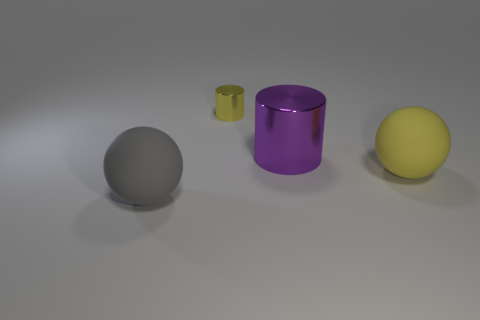Subtract all yellow cylinders. How many cylinders are left? 1 Add 4 big purple metal things. How many objects exist? 8 Subtract all blue spheres. Subtract all brown cylinders. How many spheres are left? 2 Subtract all purple objects. Subtract all red matte balls. How many objects are left? 3 Add 1 big cylinders. How many big cylinders are left? 2 Add 3 large gray rubber cylinders. How many large gray rubber cylinders exist? 3 Subtract 1 yellow spheres. How many objects are left? 3 Subtract 1 cylinders. How many cylinders are left? 1 